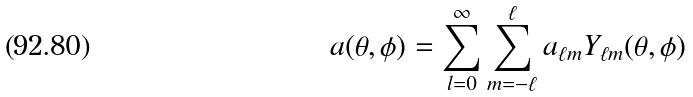Convert formula to latex. <formula><loc_0><loc_0><loc_500><loc_500>a ( \theta , \phi ) = \sum _ { l = 0 } ^ { \infty } \sum _ { m = - \ell } ^ { \ell } a _ { \ell m } Y _ { \ell m } ( \theta , \phi )</formula> 